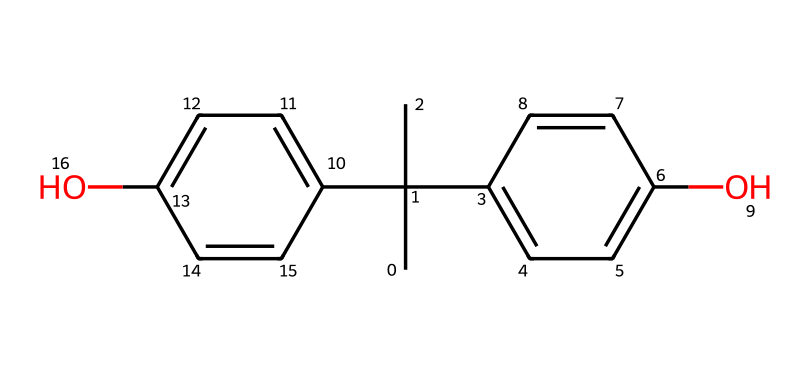What is the molecular formula of bisphenol A? To determine the molecular formula from the SMILES representation, identify the elements and their counts. The structure includes carbon (C), hydrogen (H), and oxygen (O) atoms. Counting each, we find 15 carbon atoms, 16 hydrogen atoms, and 2 oxygen atoms, leading to the molecular formula C15H16O2.
Answer: C15H16O2 How many hydroxyl (-OH) groups are present in bisphenol A? By examining the chemical structure, we can identify the functional groups. There are two hydroxyl groups attached to the aromatic rings in the structure. Thus, the count of -OH groups is straightforward from visual inspection.
Answer: 2 What type of chemical is bisphenol A? Bisphenol A is classified as a phenolic compound based on its structure, which contains two hydroxyl groups attached to aromatic rings. This classification is evident because phenols are characterized by this arrangement of hydroxyl groups on benzene-like rings.
Answer: phenol What is the total number of carbon atoms in bisphenol A? The total number of carbon atoms can be determined directly from the SMILES representation by counting the 'C' symbols, which indicates each carbon atom present. In this case, a detailed count indicates that there are 15 carbon atoms in the molecule.
Answer: 15 How many rings are present in the structure of bisphenol A? Analyzing the structure reveals that there are two aromatic rings (benzene-like structures) in bisphenol A. These can be identified by looking for the cyclic arrangements of carbon atoms in the representation.
Answer: 2 Is bisphenol A a solid or liquid at room temperature? Reviewing physical properties of bisphenol A, it is known to be a solid at room temperature due to its melting point, which is above typical room temperature (around 160°C). This solid state reflects its structural characteristics as a phenolic compound.
Answer: solid 